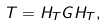Convert formula to latex. <formula><loc_0><loc_0><loc_500><loc_500>T = H _ { T } G H _ { T } ,</formula> 